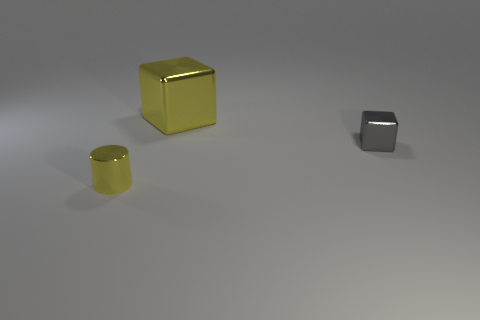Are there any tiny shiny cubes in front of the shiny cylinder?
Give a very brief answer. No. Do the small block and the yellow cylinder have the same material?
Keep it short and to the point. Yes. There is another shiny object that is the same shape as the big thing; what is its color?
Make the answer very short. Gray. Do the shiny object that is behind the tiny block and the small shiny block have the same color?
Make the answer very short. No. The object that is the same color as the small metallic cylinder is what shape?
Your answer should be compact. Cube. What number of objects have the same material as the yellow block?
Give a very brief answer. 2. What number of shiny things are behind the tiny gray shiny cube?
Your response must be concise. 1. How big is the yellow metal cube?
Ensure brevity in your answer.  Large. The block that is the same size as the yellow shiny cylinder is what color?
Your response must be concise. Gray. Is there a tiny rubber cylinder that has the same color as the large shiny cube?
Offer a terse response. No. 